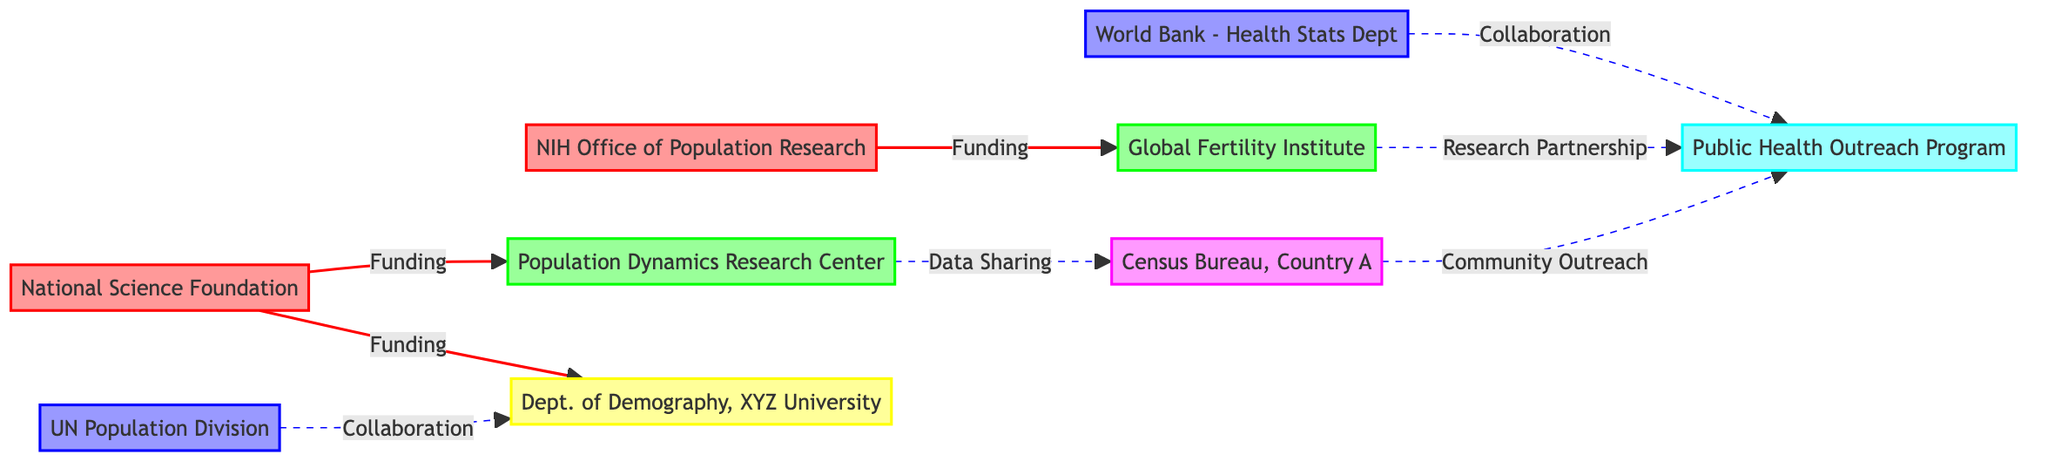What are the types of nodes present in the diagram? The diagram presents five types of nodes: Funding Source, Research Institution, International Organization, Academic Department, Government Agency, and Non-Profit Organization. Each node type represents different entities related to population dynamics and research funding.
Answer: Funding Source, Research Institution, International Organization, Academic Department, Government Agency, Non-Profit Organization How many funding sources are in the network? The diagram shows two funding sources: the National Science Foundation and the NIH Office of Population Research. These nodes are connected directly to research institutions through funding relationships.
Answer: 2 Which research institution receives funding from the National Science Foundation? The National Science Foundation funds the Population Dynamics Research Center and the Department of Demography, XYZ University, as indicated by the edges originating from that node.
Answer: Population Dynamics Research Center, Department of Demography, XYZ University What type of relationship exists between the Global Fertility Institute and the Public Health Outreach Program? The Global Fertility Institute has a research partnership with the Public Health Outreach Program, as shown by the edge that connects these two nodes. This indicates collaboration in research activities and contributions to public health.
Answer: Research Partnership Which node collaborates with the World Bank - Health Statistics Department? The World Bank - Health Statistics Department collaborates with the Public Health Outreach Program, indicating a collaborative relationship aimed at enhancing health statistics and outreach efforts.
Answer: Public Health Outreach Program How many total edges are displayed in the diagram? The diagram contains seven edges, representing various relationships such as funding, collaboration, and data sharing between the nodes. Counting these edges gives us the total connections in the network.
Answer: 7 Which organization collaborates with the Census Bureau, Country A? The Population Dynamics Research Center collaborates with the Census Bureau, Country A, as indicated by the data-sharing edge that connects these two nodes, emphasizing their joint efforts in demographic data.
Answer: Population Dynamics Research Center Is there a direct funding edge from NIH Office of Population Research to the Population Dynamics Research Center? No, there is no direct funding edge from the NIH Office of Population Research to the Population Dynamics Research Center; instead, it funds the Global Fertility Institute. This is confirmed by tracing the edges leading from each funding source in the diagram.
Answer: No Which type of organizations share data in the network? The diagram displays collaborations and data sharing primarily among research institutions, governmental agencies, and non-profit organizations, indicating their role in population dynamics efforts.
Answer: Research Institutions, Governmental Agencies, Non-Profit Organizations 